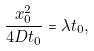Convert formula to latex. <formula><loc_0><loc_0><loc_500><loc_500>\frac { x _ { 0 } ^ { 2 } } { 4 D t _ { 0 } } = \lambda t _ { 0 } ,</formula> 